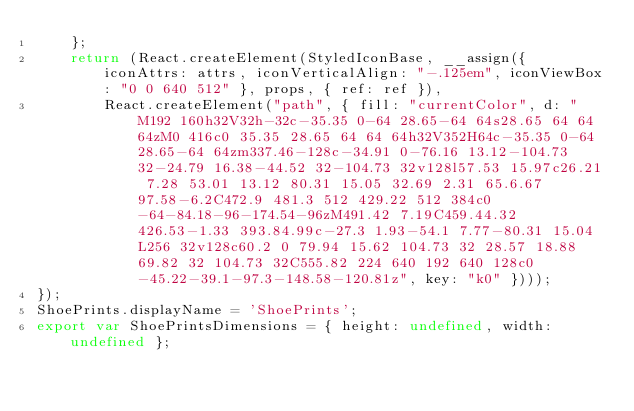<code> <loc_0><loc_0><loc_500><loc_500><_JavaScript_>    };
    return (React.createElement(StyledIconBase, __assign({ iconAttrs: attrs, iconVerticalAlign: "-.125em", iconViewBox: "0 0 640 512" }, props, { ref: ref }),
        React.createElement("path", { fill: "currentColor", d: "M192 160h32V32h-32c-35.35 0-64 28.65-64 64s28.65 64 64 64zM0 416c0 35.35 28.65 64 64 64h32V352H64c-35.35 0-64 28.65-64 64zm337.46-128c-34.91 0-76.16 13.12-104.73 32-24.79 16.38-44.52 32-104.73 32v128l57.53 15.97c26.21 7.28 53.01 13.12 80.31 15.05 32.69 2.31 65.6.67 97.58-6.2C472.9 481.3 512 429.22 512 384c0-64-84.18-96-174.54-96zM491.42 7.19C459.44.32 426.53-1.33 393.84.99c-27.3 1.93-54.1 7.77-80.31 15.04L256 32v128c60.2 0 79.94 15.62 104.73 32 28.57 18.88 69.82 32 104.73 32C555.82 224 640 192 640 128c0-45.22-39.1-97.3-148.58-120.81z", key: "k0" })));
});
ShoePrints.displayName = 'ShoePrints';
export var ShoePrintsDimensions = { height: undefined, width: undefined };
</code> 